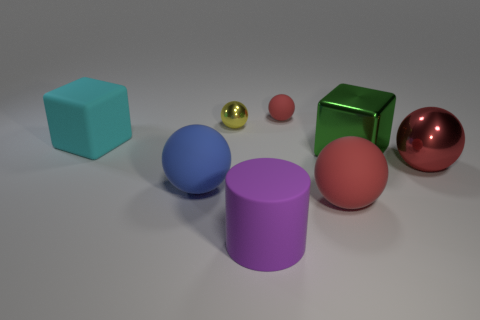Subtract all gray cubes. How many red balls are left? 3 Subtract all blue balls. How many balls are left? 4 Subtract all red metallic balls. How many balls are left? 4 Subtract all gray balls. Subtract all yellow blocks. How many balls are left? 5 Add 1 green objects. How many objects exist? 9 Subtract all spheres. How many objects are left? 3 Add 1 purple metallic spheres. How many purple metallic spheres exist? 1 Subtract 0 brown blocks. How many objects are left? 8 Subtract all small cyan metal blocks. Subtract all cyan matte blocks. How many objects are left? 7 Add 7 large red shiny objects. How many large red shiny objects are left? 8 